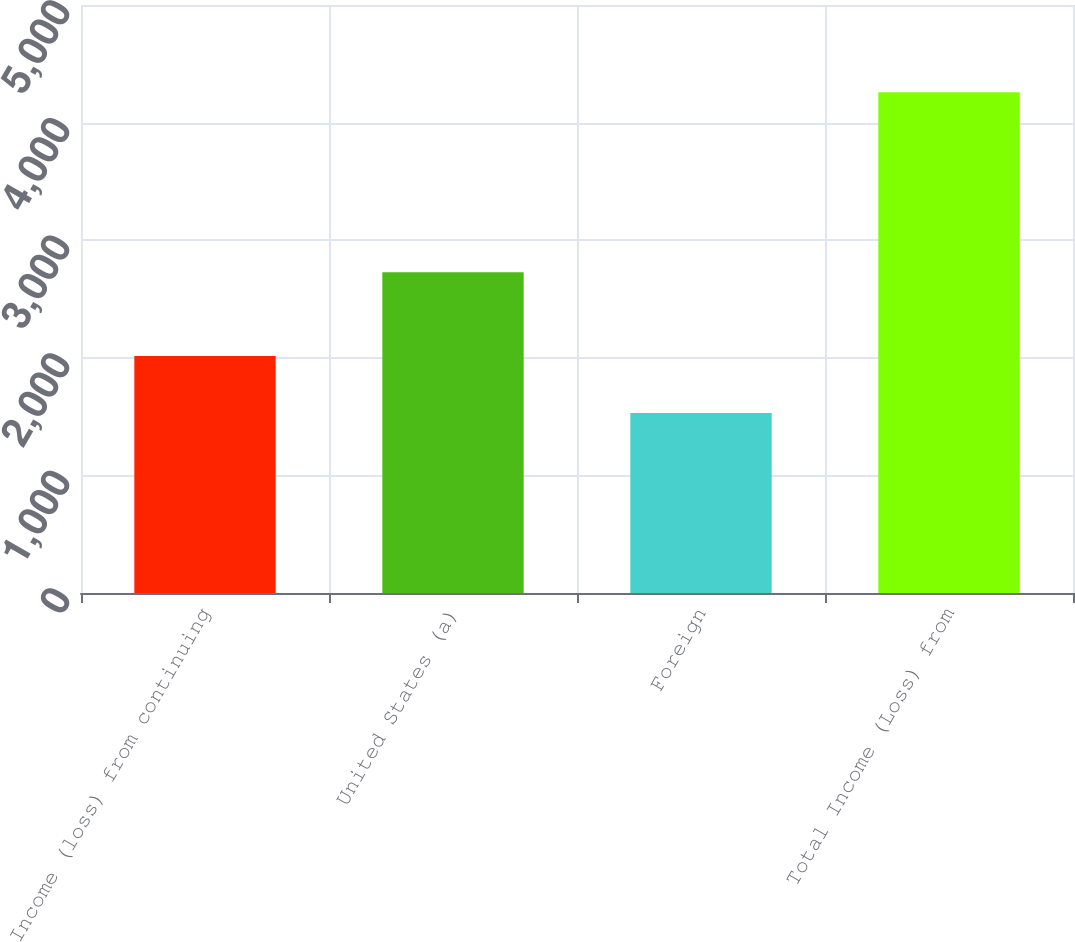Convert chart to OTSL. <chart><loc_0><loc_0><loc_500><loc_500><bar_chart><fcel>Income (loss) from continuing<fcel>United States (a)<fcel>Foreign<fcel>Total Income (Loss) from<nl><fcel>2015<fcel>2728<fcel>1530<fcel>4258<nl></chart> 